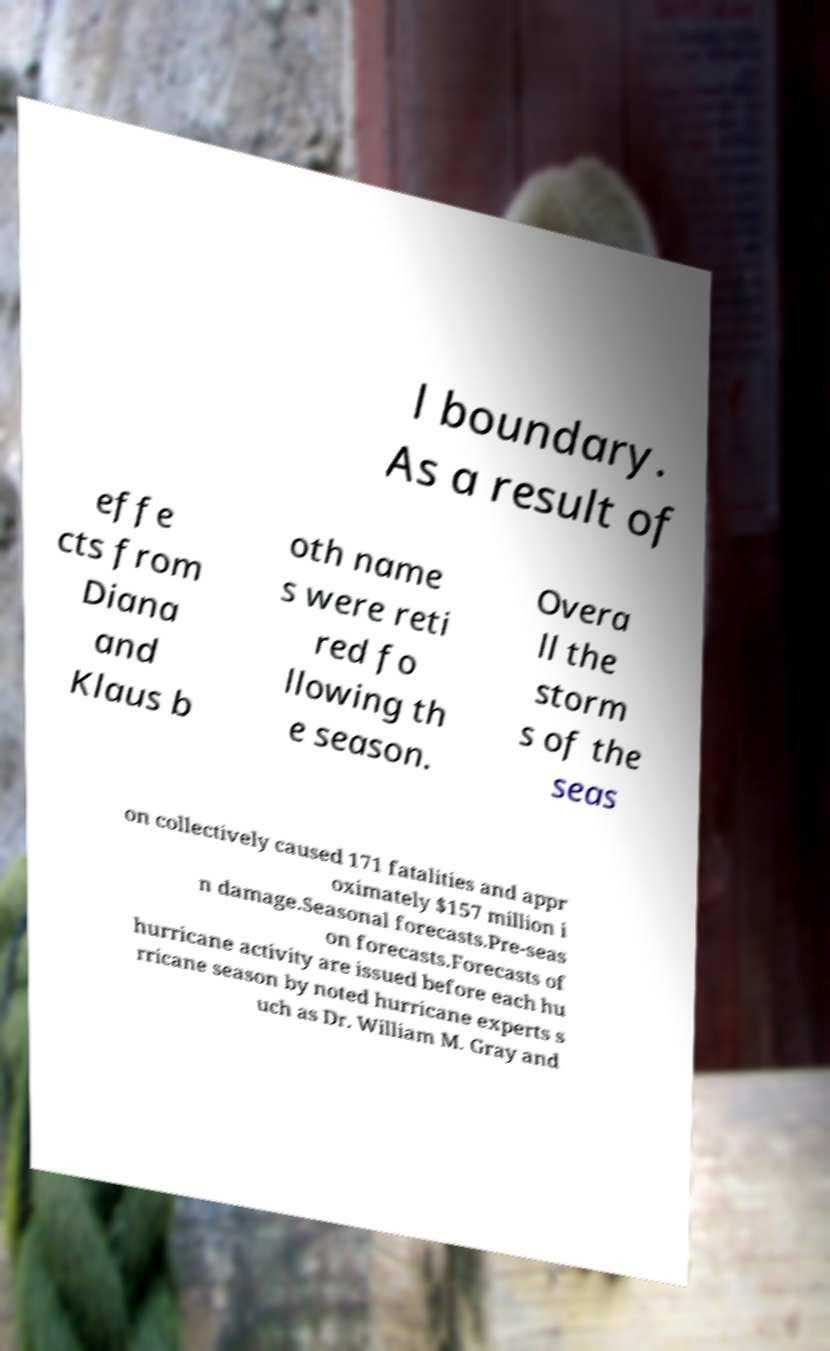For documentation purposes, I need the text within this image transcribed. Could you provide that? l boundary. As a result of effe cts from Diana and Klaus b oth name s were reti red fo llowing th e season. Overa ll the storm s of the seas on collectively caused 171 fatalities and appr oximately $157 million i n damage.Seasonal forecasts.Pre-seas on forecasts.Forecasts of hurricane activity are issued before each hu rricane season by noted hurricane experts s uch as Dr. William M. Gray and 